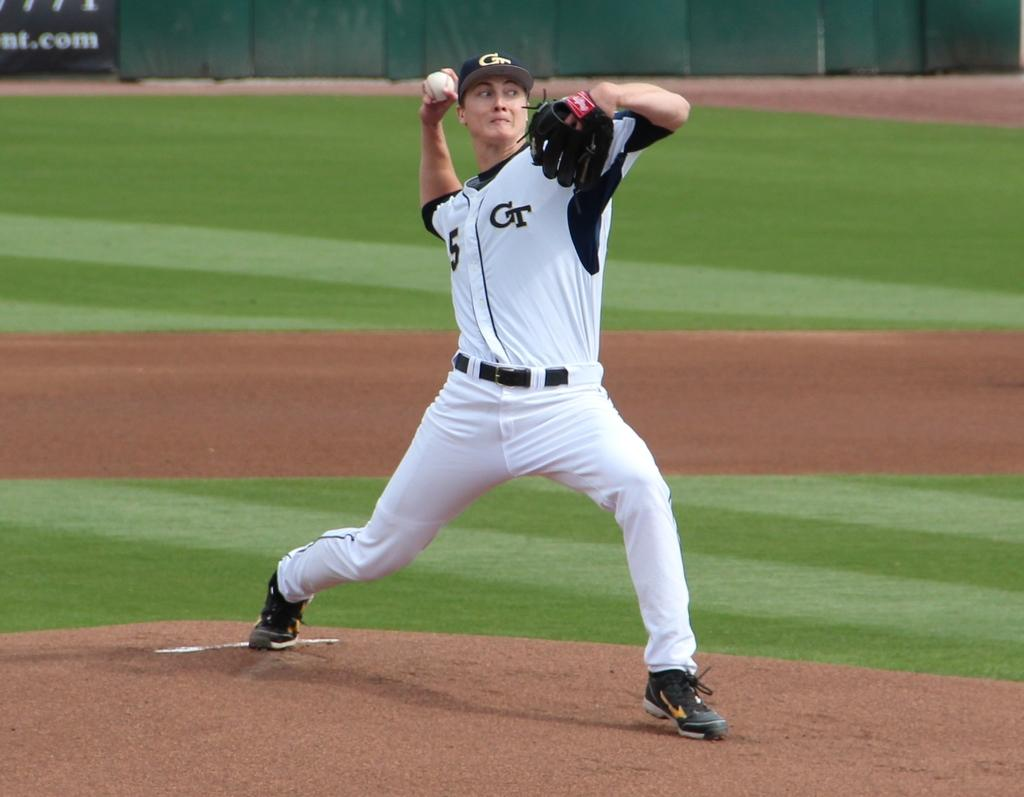<image>
Provide a brief description of the given image. A baseball pitcher is wearing a number 5 on his blue and white CT shirt. 